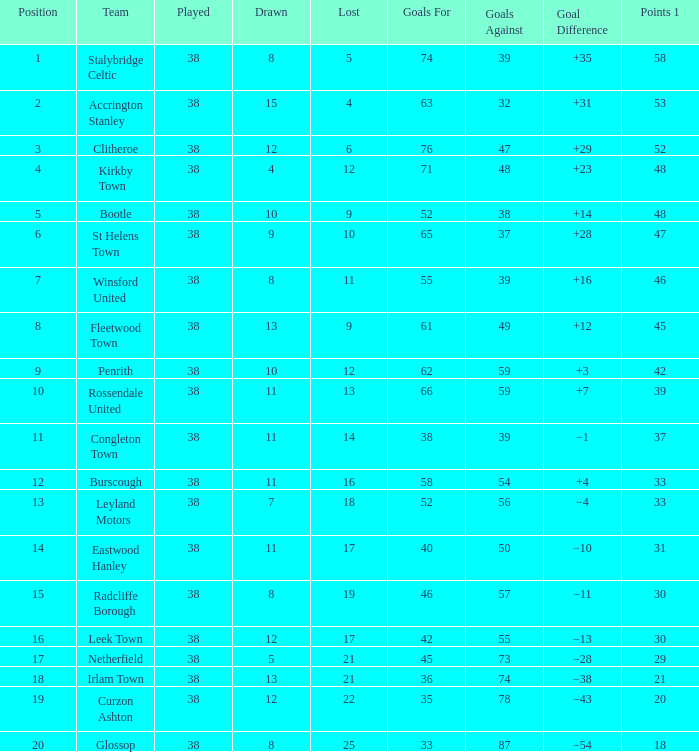What is the total number of goals that has been played less than 38 times? 0.0. 